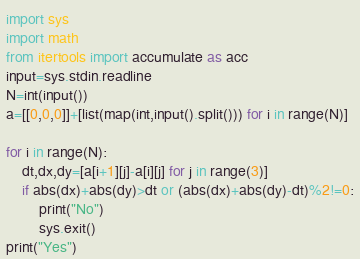<code> <loc_0><loc_0><loc_500><loc_500><_Python_>import sys
import math
from itertools import accumulate as acc
input=sys.stdin.readline
N=int(input())
a=[[0,0,0]]+[list(map(int,input().split())) for i in range(N)]

for i in range(N):
    dt,dx,dy=[a[i+1][j]-a[i][j] for j in range(3)]
    if abs(dx)+abs(dy)>dt or (abs(dx)+abs(dy)-dt)%2!=0:
        print("No")
        sys.exit()
print("Yes")</code> 